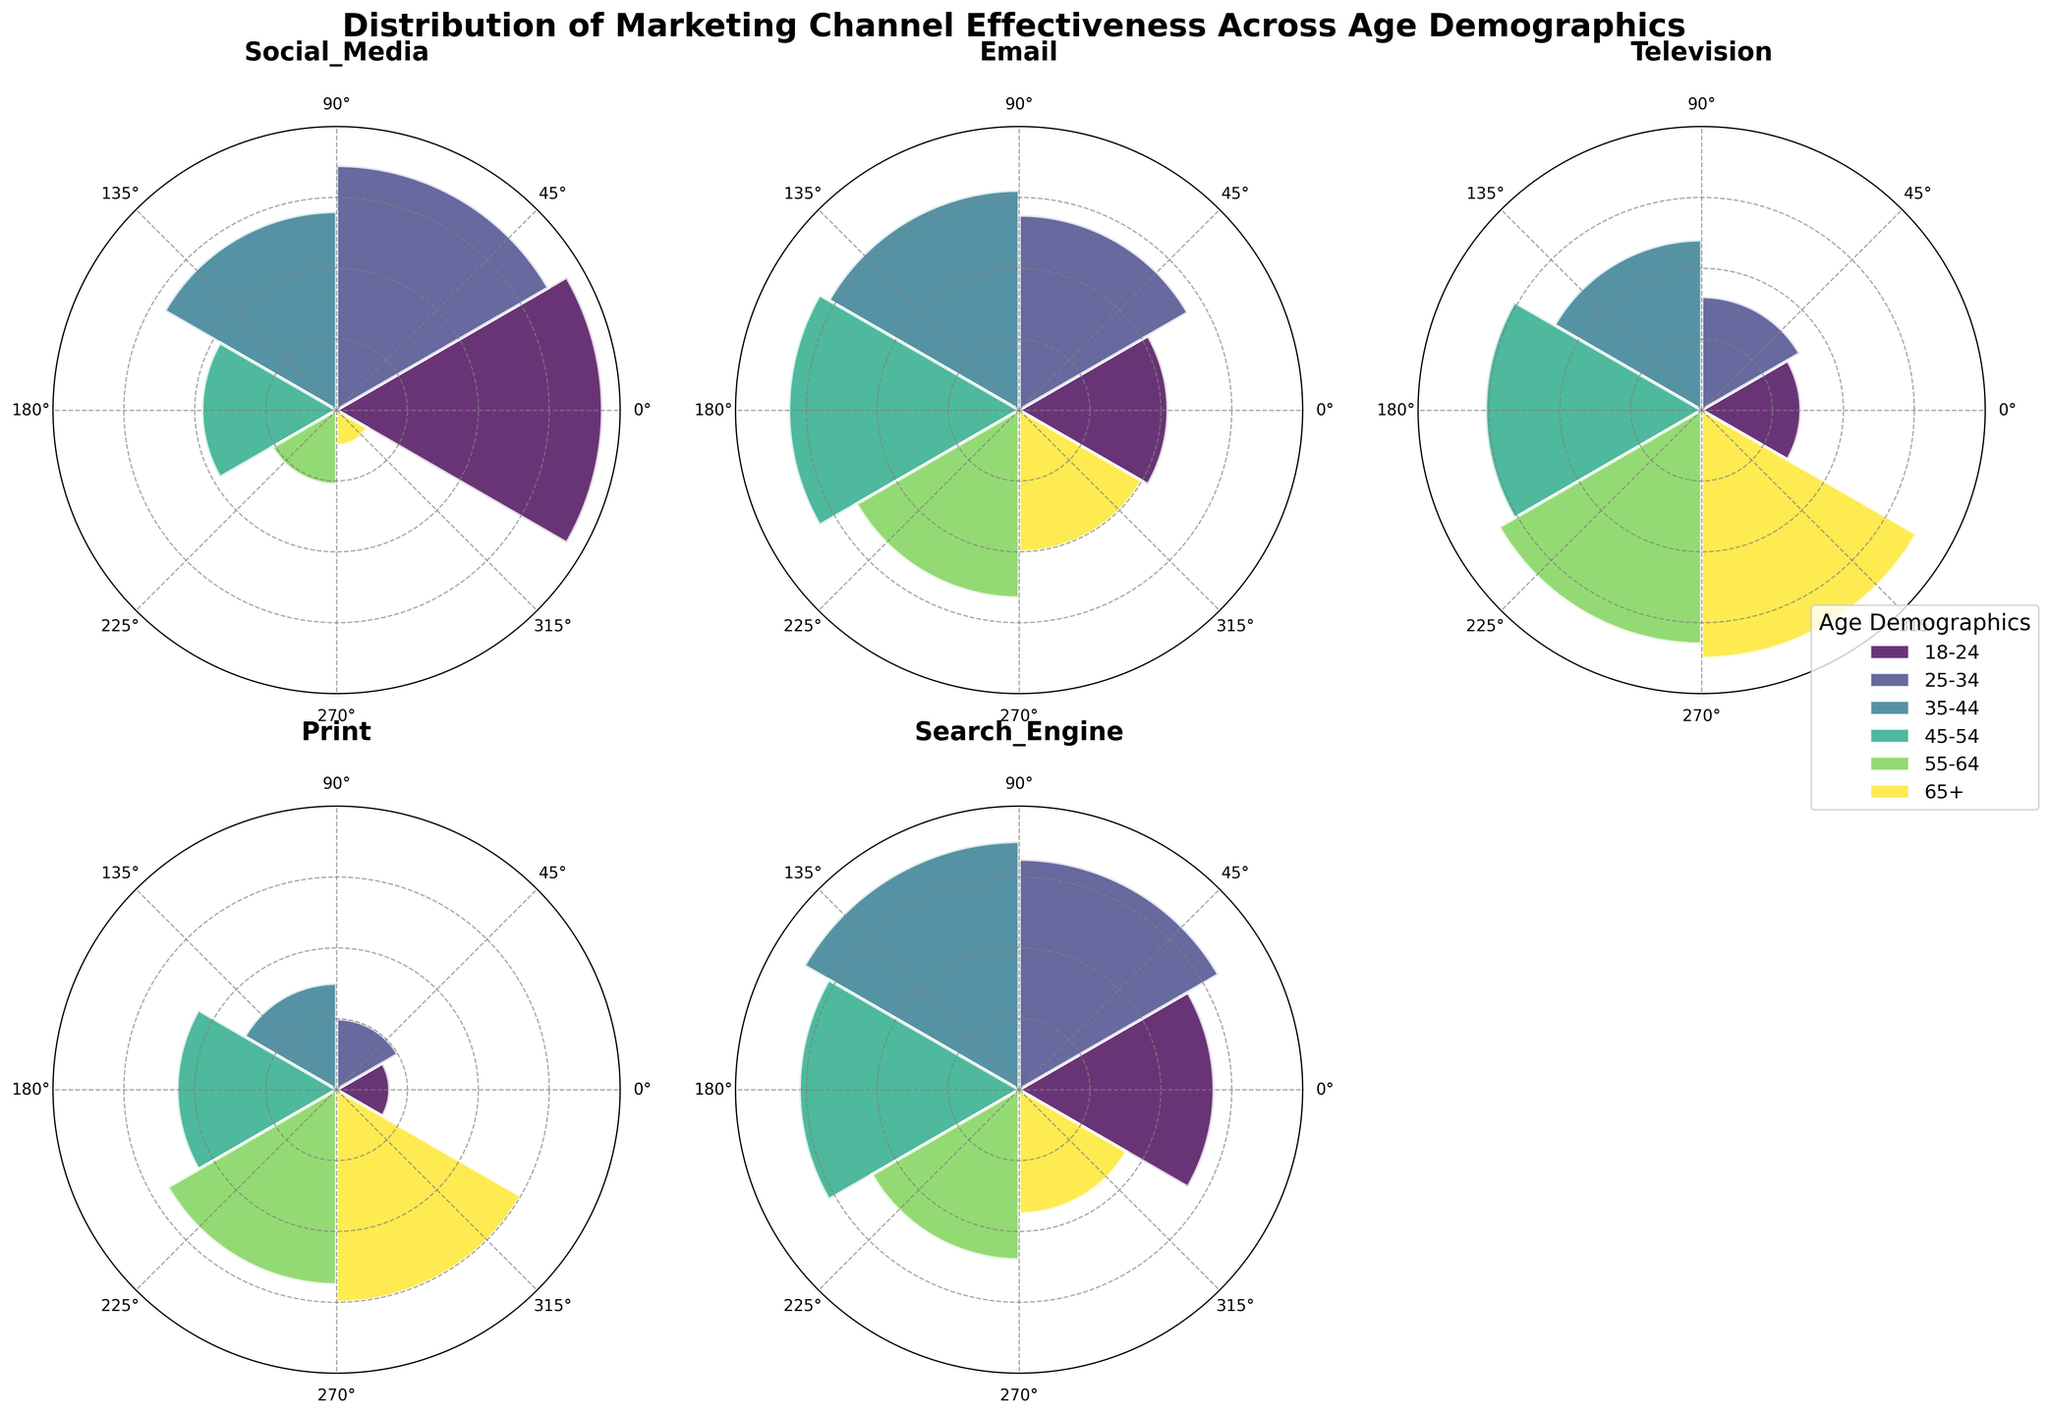What is the title of the plot? The title of the plot is located at the top of the figure and gives a summary of what the visual represents. It reads 'Distribution of Marketing Channel Effectiveness Across Age Demographics.'
Answer: Distribution of Marketing Channel Effectiveness Across Age Demographics Which age group has the highest effectiveness score for Social Media? By looking at the Social Media subplot, the bar representing the 18-24 age group is the tallest, indicating it has the highest score.
Answer: 18-24 How does Email effectiveness compare between the 25-34 and 45-54 age groups? In the Email subplot, the bar for the 45-54 age group is higher than the one for the 25-34 age group, indicating that Email is more effective for the 45-54 age group than for the 25-34 age group.
Answer: 45-54 is higher What is the average effectiveness score for Print across all age demographics? The effectiveness scores for Print across all age groups are 15, 20, 30, 45, 55, and 60. To find the average, sum up these values (15 + 20 + 30 + 45 + 55 + 60 = 225) and then divide by the number of age groups (6). The average effectiveness score is 225/6 = 37.5.
Answer: 37.5 Which marketing channel is most effective for the 65+ age group? By observing all the subplots, the bar representing the 65+ age group is tallest for Television, indicating that Television is the most effective marketing channel for this age group.
Answer: Television For which age group does Search Engine marketing show a decreasing trend in effectiveness scores compared to younger age groups? In the Search Engine subplot, the effectiveness starts high at 55 for the 18-24 age group and increases until the 35-44 age group, after which it decreases. So, the decreasing trend starts after the 35-44 age group.
Answer: 45-54 and older Is there an age demographic where all marketing channels have effectiveness scores below 30? No age demographic has all marketing channels scoring below 30. For instance, in the 65+ age group, Print, Email, and Television have effectiveness scores above 30.
Answer: No Which marketing channel shows the least variation in effectiveness scores across all age demographics? Examining all subplots, Email appears to have the least variation as its scores are relatively closer to each other compared to other channels.
Answer: Email 